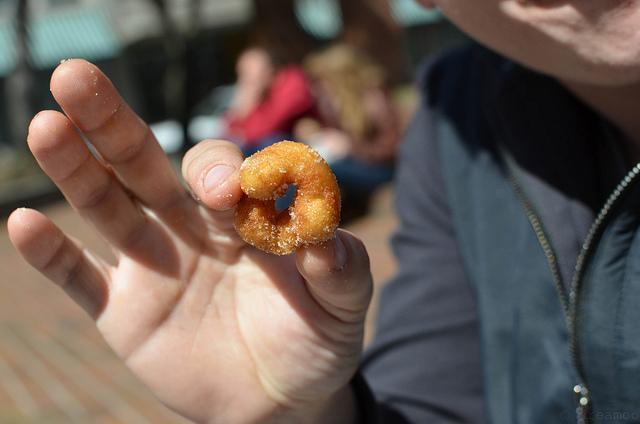What is the man holding?
Answer the question by selecting the correct answer among the 4 following choices and explain your choice with a short sentence. The answer should be formatted with the following format: `Answer: choice
Rationale: rationale.`
Options: Chicken ring, cinnamon roll, zeppole, calamari. Answer: zeppole.
Rationale: The man is holding a round piece of breaded chicken with a hole in the middle. 